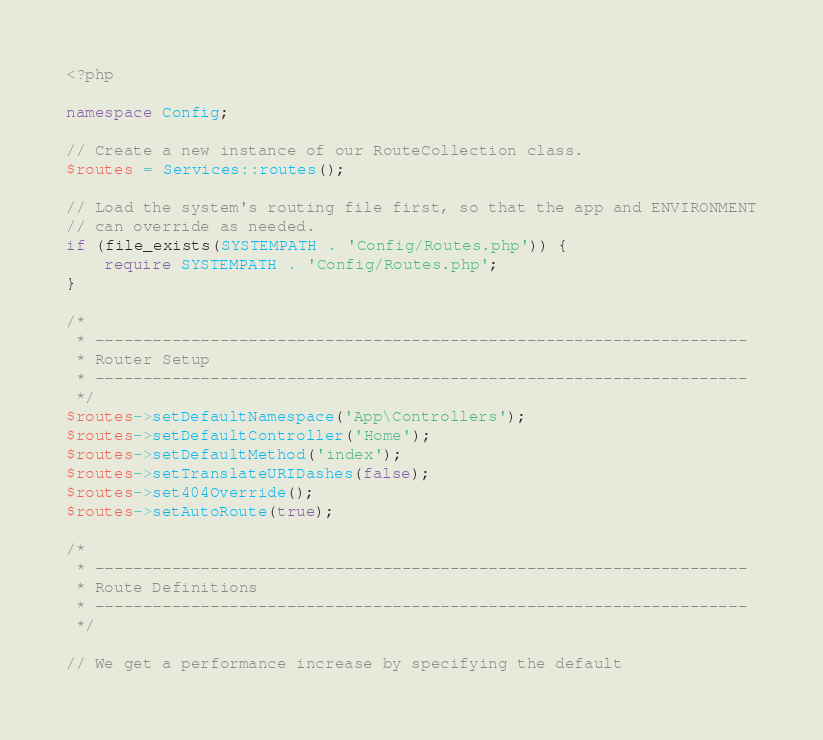Convert code to text. <code><loc_0><loc_0><loc_500><loc_500><_PHP_><?php

namespace Config;

// Create a new instance of our RouteCollection class.
$routes = Services::routes();

// Load the system's routing file first, so that the app and ENVIRONMENT
// can override as needed.
if (file_exists(SYSTEMPATH . 'Config/Routes.php')) {
    require SYSTEMPATH . 'Config/Routes.php';
}

/*
 * --------------------------------------------------------------------
 * Router Setup
 * --------------------------------------------------------------------
 */
$routes->setDefaultNamespace('App\Controllers');
$routes->setDefaultController('Home');
$routes->setDefaultMethod('index');
$routes->setTranslateURIDashes(false);
$routes->set404Override();
$routes->setAutoRoute(true);

/*
 * --------------------------------------------------------------------
 * Route Definitions
 * --------------------------------------------------------------------
 */

// We get a performance increase by specifying the default</code> 